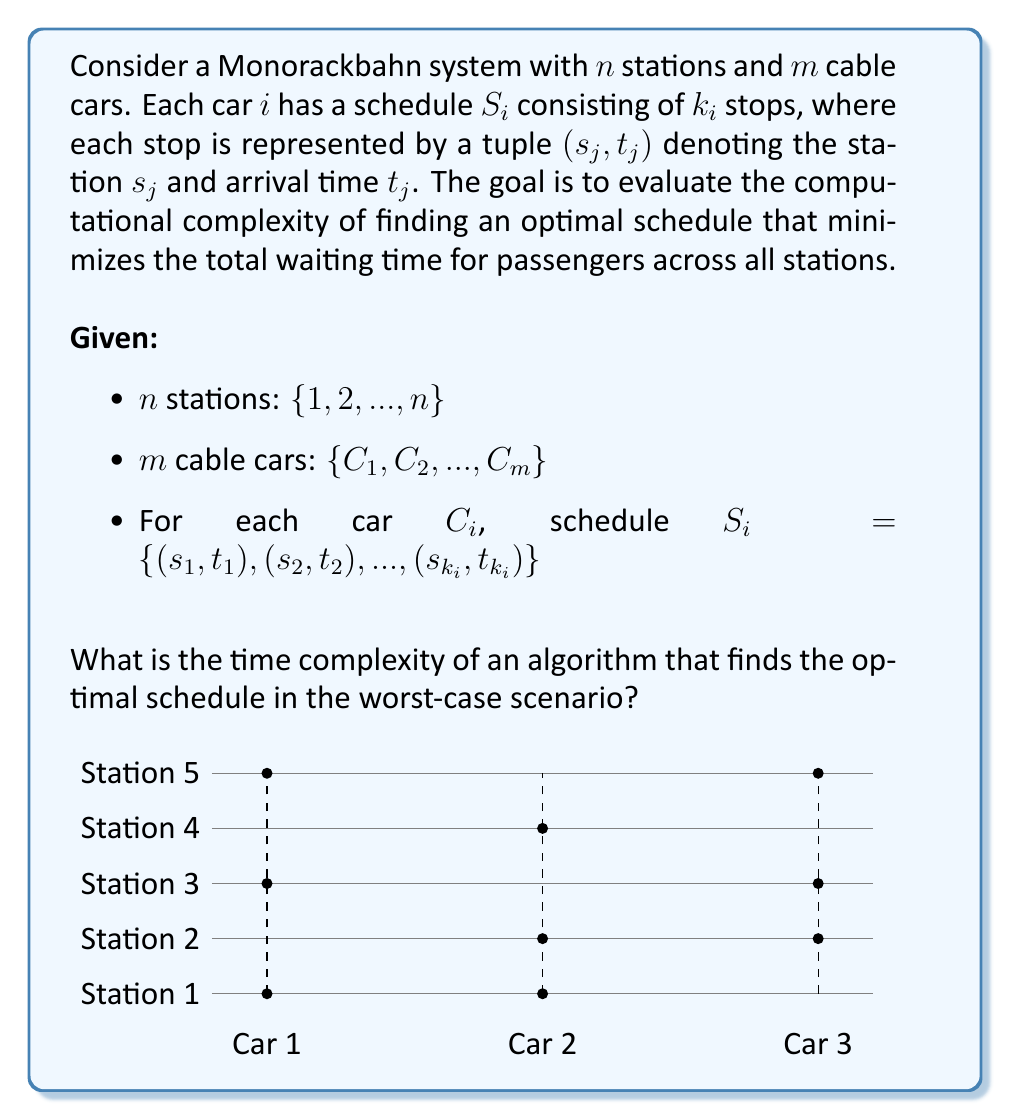Solve this math problem. To analyze the computational complexity of finding an optimal schedule for the Monorackbahn system, we need to consider the following steps:

1) First, we need to understand that this problem is essentially a variation of the Job Shop Scheduling problem, which is known to be NP-hard.

2) In our case, the stations are analogous to machines, and the cable cars are analogous to jobs.

3) The total number of possible schedules is determined by the number of permutations of stops for all cars. For each car $C_i$, there are $k_i!$ possible orderings of its stops.

4) Therefore, the total number of possible schedules is:

   $$\prod_{i=1}^m k_i!$$

5) In the worst case, each car visits all stations, so $k_i = n$ for all $i$. This gives us:

   $$\prod_{i=1}^m n! = (n!)^m$$

6) To find the optimal schedule, we would need to evaluate each of these possibilities, which gives us a lower bound on the time complexity.

7) Using Stirling's approximation, we can estimate $n!$ as:

   $$n! \approx \sqrt{2\pi n} (\frac{n}{e})^n$$

8) Therefore, the time complexity in the worst case is at least:

   $$O((\sqrt{2\pi n} (\frac{n}{e})^n)^m) = O(((\frac{n}{e})^n)^m) = O((\frac{n}{e})^{nm})$$

9) This is a super-exponential time complexity, which means the problem is intractable for large values of $n$ and $m$.

10) It's worth noting that there are heuristic algorithms and approximation methods that can provide near-optimal solutions in polynomial time, but finding the exact optimal solution in the general case remains NP-hard.
Answer: $O((\frac{n}{e})^{nm})$ 